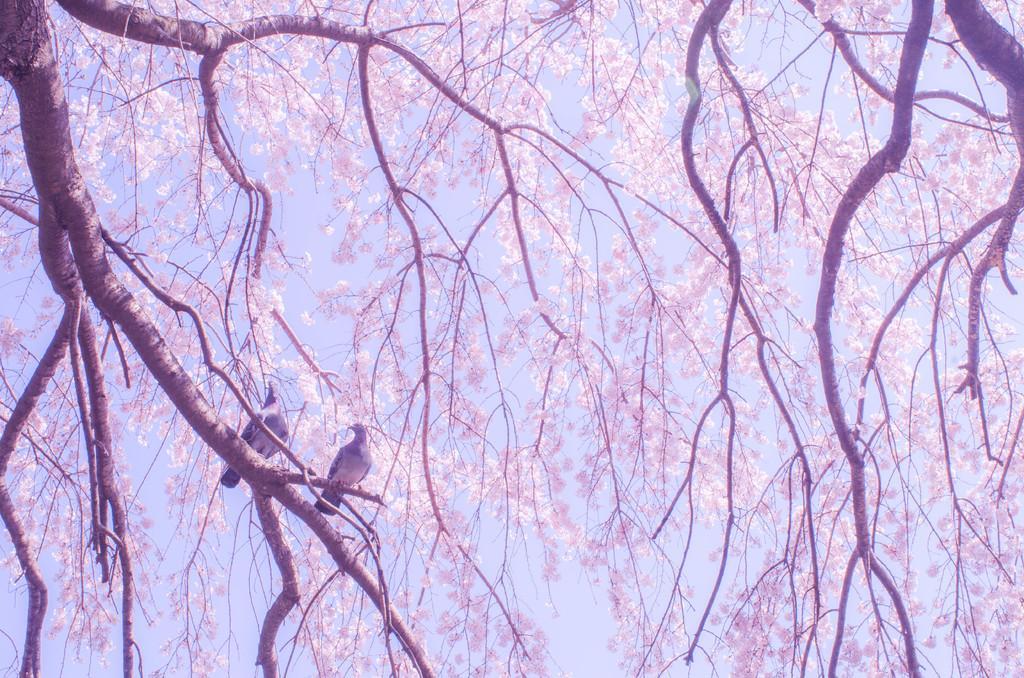Could you give a brief overview of what you see in this image? In this image, I can see the trees and two birds on a branch. In the background, there is the sky. 